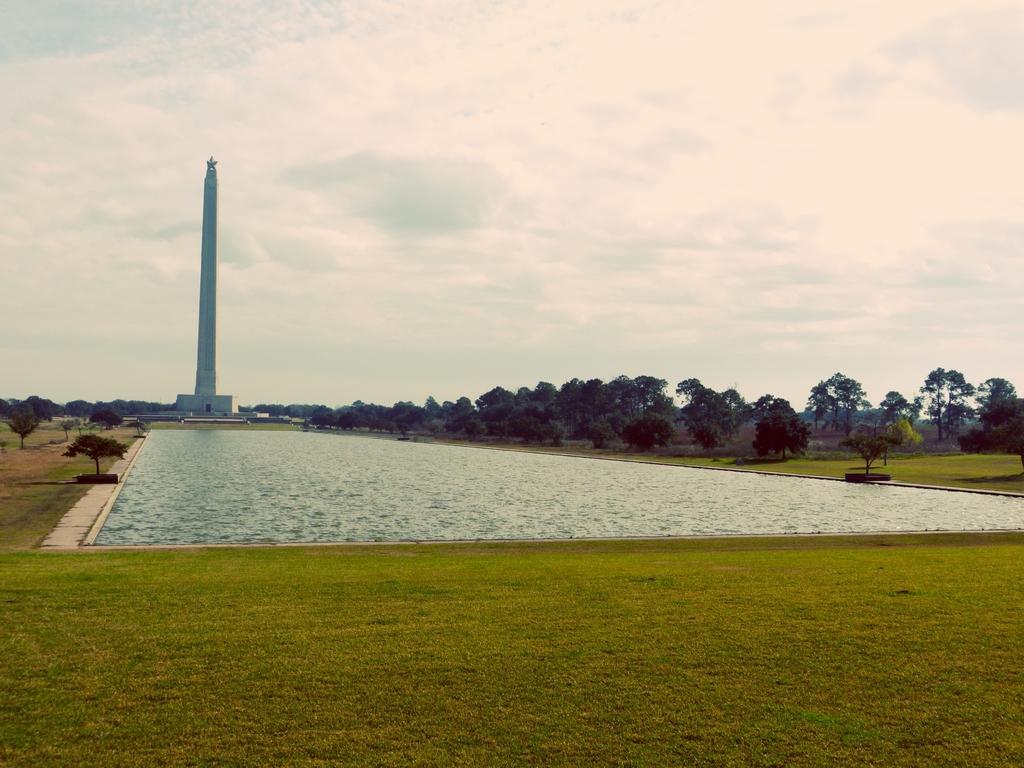In one or two sentences, can you explain what this image depicts? In this image I can see the grass and the water. On both sides of the water I can see the trees. In the background I can see the tower, clouds and the sky. 